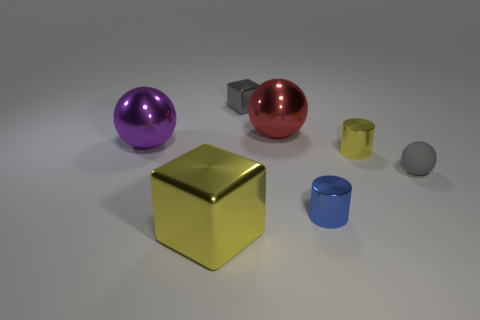What number of cyan things are small spheres or big metallic objects?
Give a very brief answer. 0. Is there anything else that is the same color as the small shiny cube?
Offer a terse response. Yes. There is a large metal object that is in front of the tiny metal object on the right side of the small blue shiny thing; what is its color?
Give a very brief answer. Yellow. Is the number of tiny yellow things left of the small gray cube less than the number of gray cubes that are to the right of the large purple metal ball?
Give a very brief answer. Yes. There is another object that is the same color as the tiny matte object; what is it made of?
Give a very brief answer. Metal. How many objects are metal cubes left of the gray metallic object or tiny brown shiny cylinders?
Offer a terse response. 1. There is a thing that is in front of the blue cylinder; does it have the same size as the tiny cube?
Make the answer very short. No. Are there fewer big red metal spheres to the left of the big red metal object than matte balls?
Your answer should be very brief. Yes. What is the material of the block that is the same size as the matte object?
Your answer should be very brief. Metal. What number of large objects are either gray cubes or blue matte balls?
Provide a succinct answer. 0. 